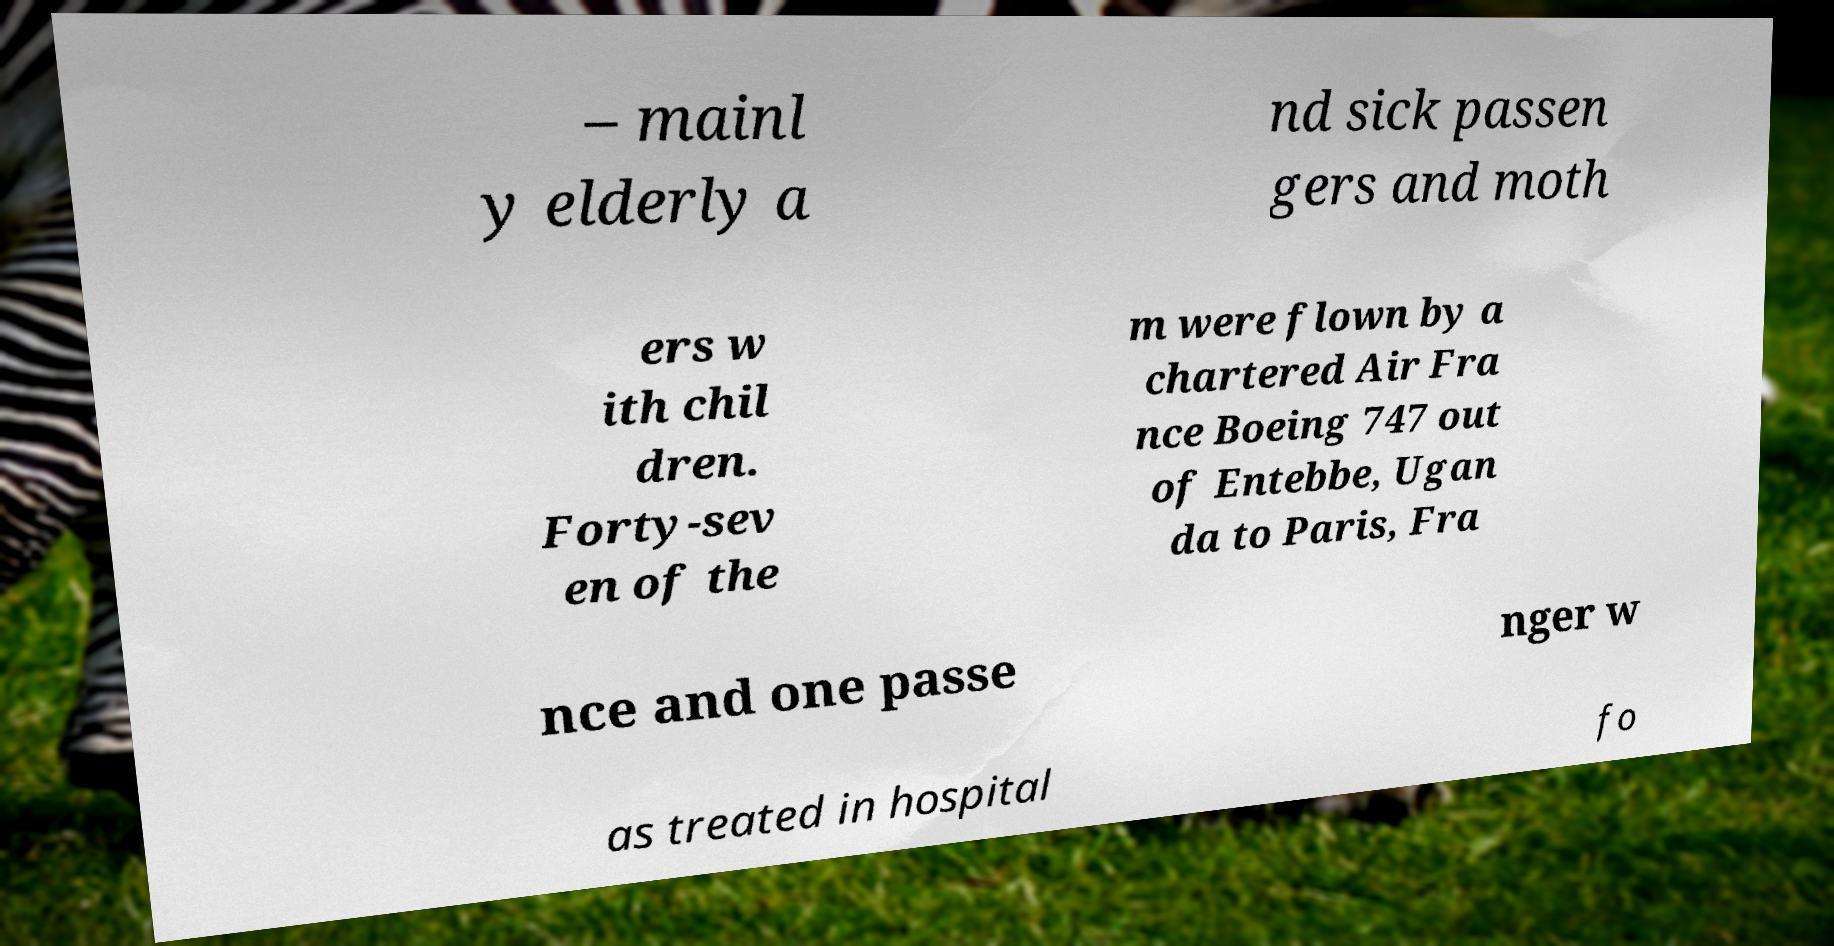Please read and relay the text visible in this image. What does it say? – mainl y elderly a nd sick passen gers and moth ers w ith chil dren. Forty-sev en of the m were flown by a chartered Air Fra nce Boeing 747 out of Entebbe, Ugan da to Paris, Fra nce and one passe nger w as treated in hospital fo 